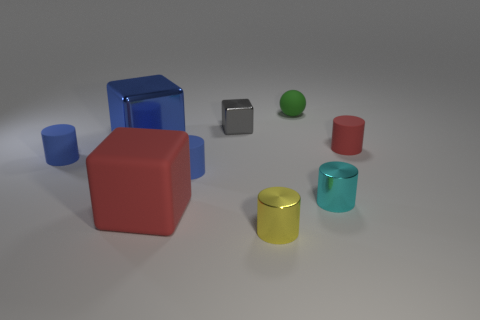Subtract all yellow cylinders. How many cylinders are left? 4 Subtract all small cyan metallic cylinders. How many cylinders are left? 4 Add 1 purple shiny objects. How many objects exist? 10 Subtract all green cylinders. Subtract all blue spheres. How many cylinders are left? 5 Subtract all cylinders. How many objects are left? 4 Add 3 tiny purple metallic spheres. How many tiny purple metallic spheres exist? 3 Subtract 0 yellow blocks. How many objects are left? 9 Subtract all big red shiny balls. Subtract all gray metallic objects. How many objects are left? 8 Add 6 red cubes. How many red cubes are left? 7 